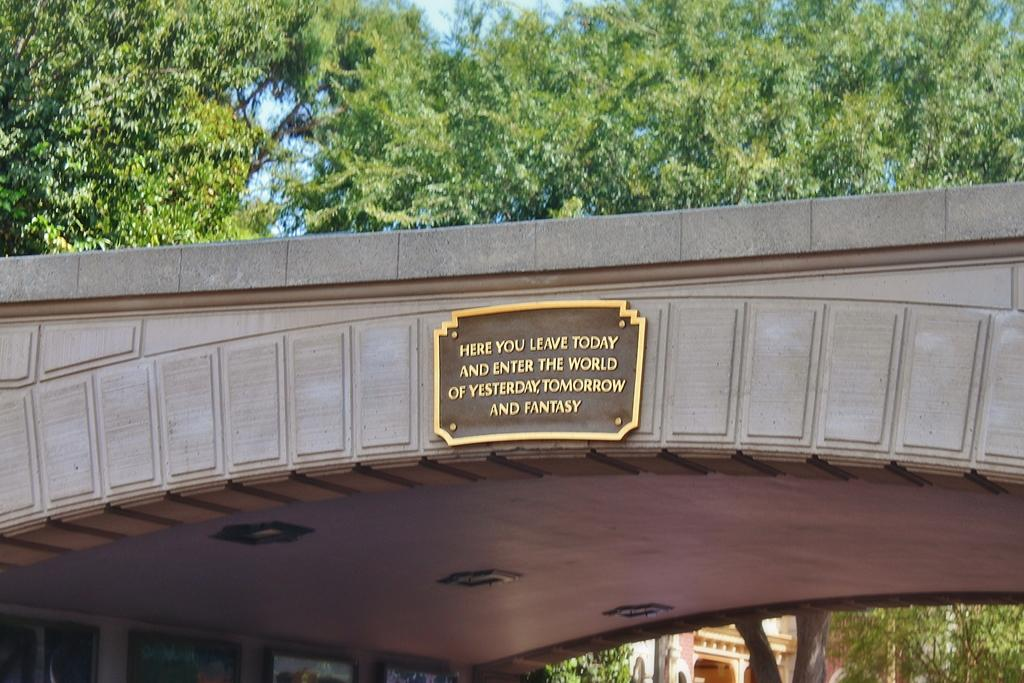<image>
Render a clear and concise summary of the photo. A bridge has a plaque that says Here you leave today. 